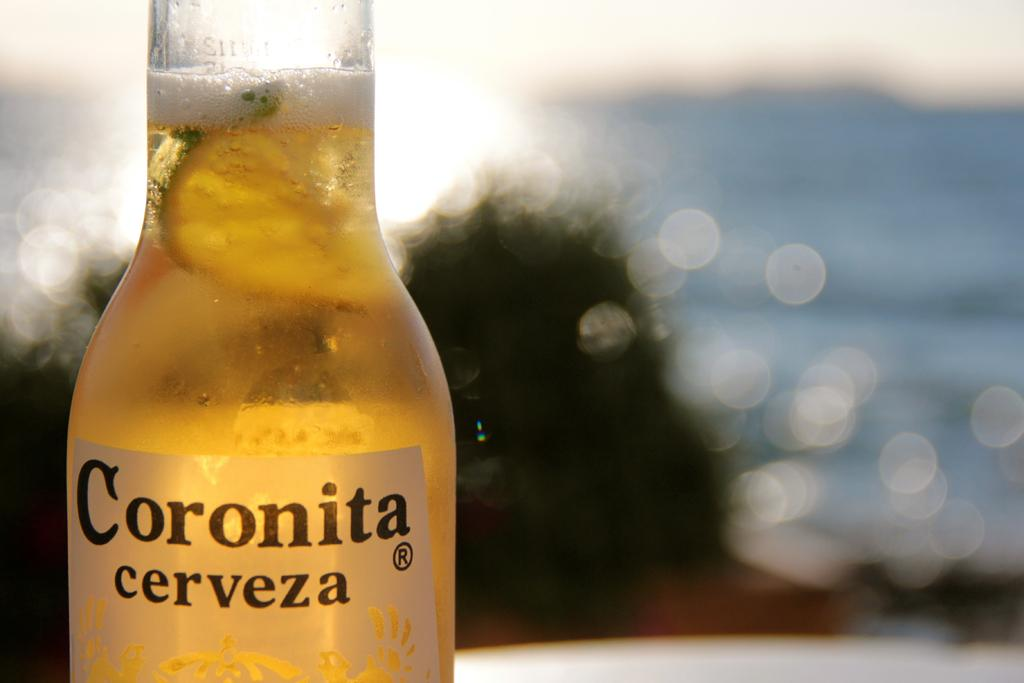<image>
Offer a succinct explanation of the picture presented. A nearly full bottle of Coronita brand Mexican beer. 